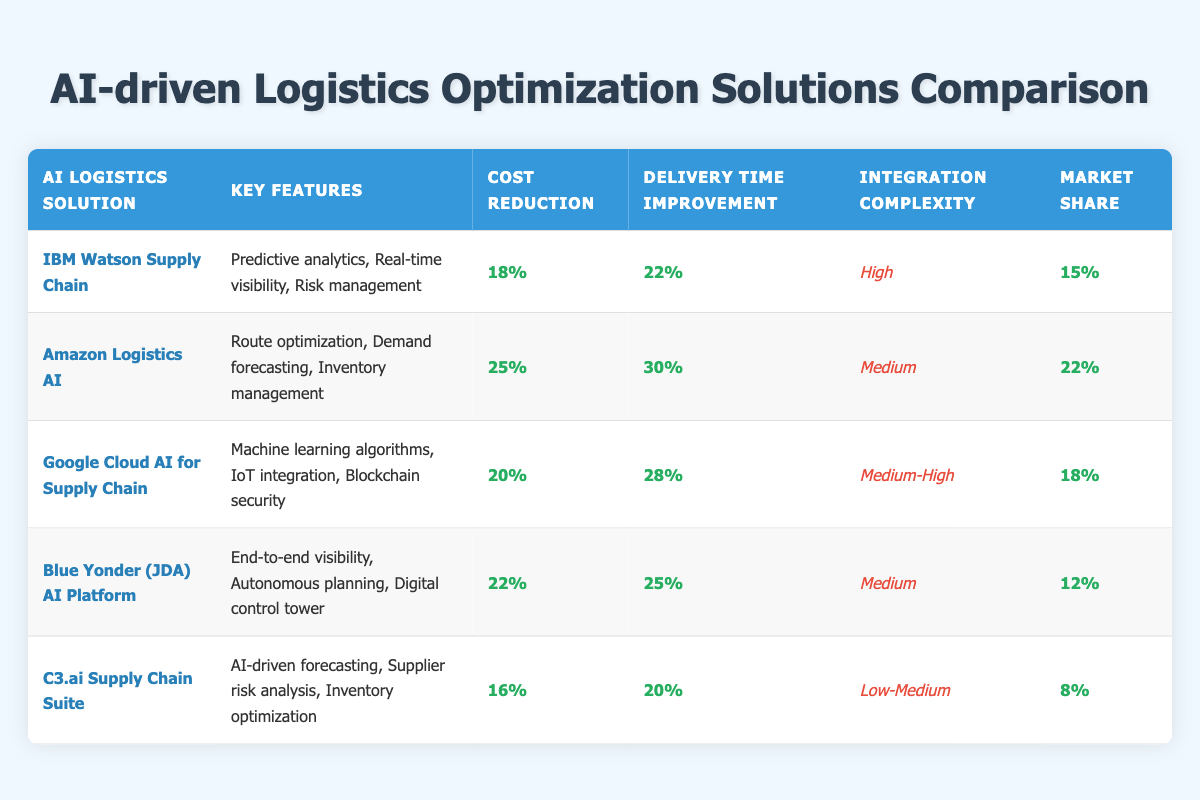What is the cost reduction percentage for Amazon Logistics AI? The table lists "Cost Reduction" for Amazon Logistics AI as 25%.
Answer: 25% Which AI logistics solution offers the highest market share? The table shows that Amazon Logistics AI has the highest market share at 22%.
Answer: 22% What is the average delivery time improvement across all solutions? To find the average, we add the delivery time improvements: (22 + 30 + 28 + 25 + 20) = 125. There are 5 solutions, so the average delivery time improvement is 125 / 5 = 25%.
Answer: 25% Is it true that C3.ai Supply Chain Suite has the lowest cost reduction percentage? Yes, C3.ai Supply Chain Suite has a cost reduction of 16%, which is lower than all other listed solutions.
Answer: Yes Which solution has both a medium complexity of integration and delivers the highest improvement in delivery time? From the table, Google Cloud AI for Supply Chain has medium-high complexity and offers a delivery time improvement of 28%, which is the highest among those with medium complexity or below.
Answer: Google Cloud AI for Supply Chain What is the difference in cost reduction percentage between the highest and lowest solutions? The highest is Amazon Logistics AI with a 25% cost reduction, and the lowest is C3.ai Supply Chain Suite with 16%. The difference is 25% - 16% = 9%.
Answer: 9% Which solutions have a delivery time improvement of 25% or higher? The solutions with delivery improvements of 25% or higher are Amazon Logistics AI (30%), Google Cloud AI for Supply Chain (28%), and Blue Yonder (25%).
Answer: 3 solutions Does IBM Watson Supply Chain have a higher cost reduction percentage than Google Cloud AI for Supply Chain? No, IBM Watson Supply Chain has a cost reduction of 18%, while Google Cloud AI for Supply Chain has 20%.
Answer: No What is the total market share of the AI-driven logistics solutions listed? The total market share is the sum of all market shares: (15 + 22 + 18 + 12 + 8) = 75%.
Answer: 75% 